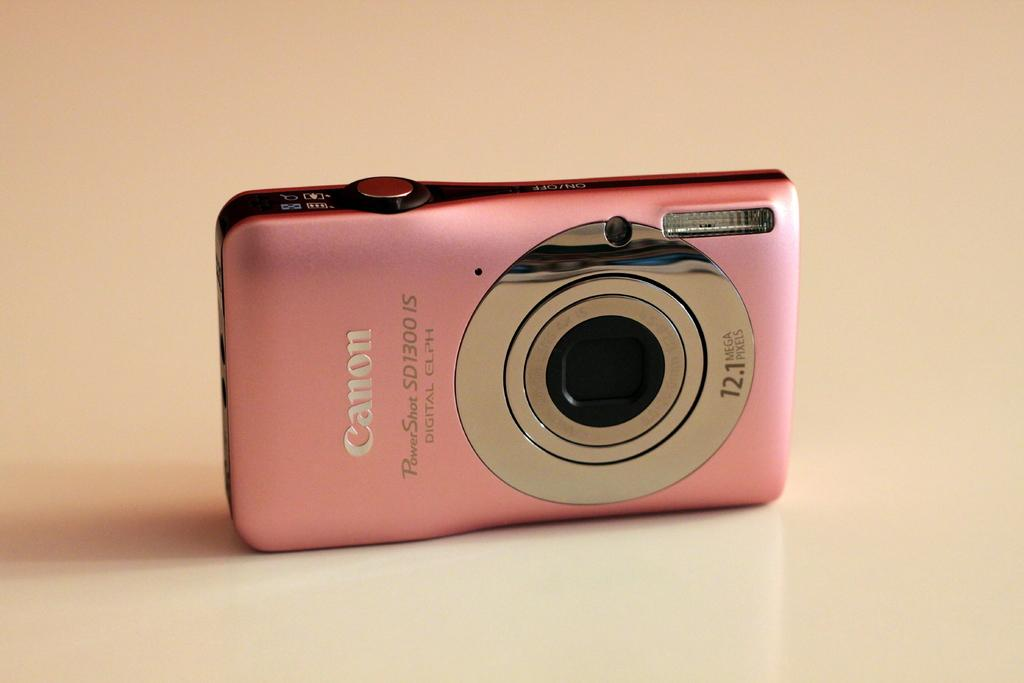What color is the camera in the image? The camera in the image is pink. What brand of camera is in the image? The camera in the image is a Canon camera. Can you tell me how many doctors are in the image? There are no doctors present in the image; it features a pink Canon camera. What type of kitty is sitting on the camera in the image? There is no kitty present in the image; it features a pink Canon camera. 